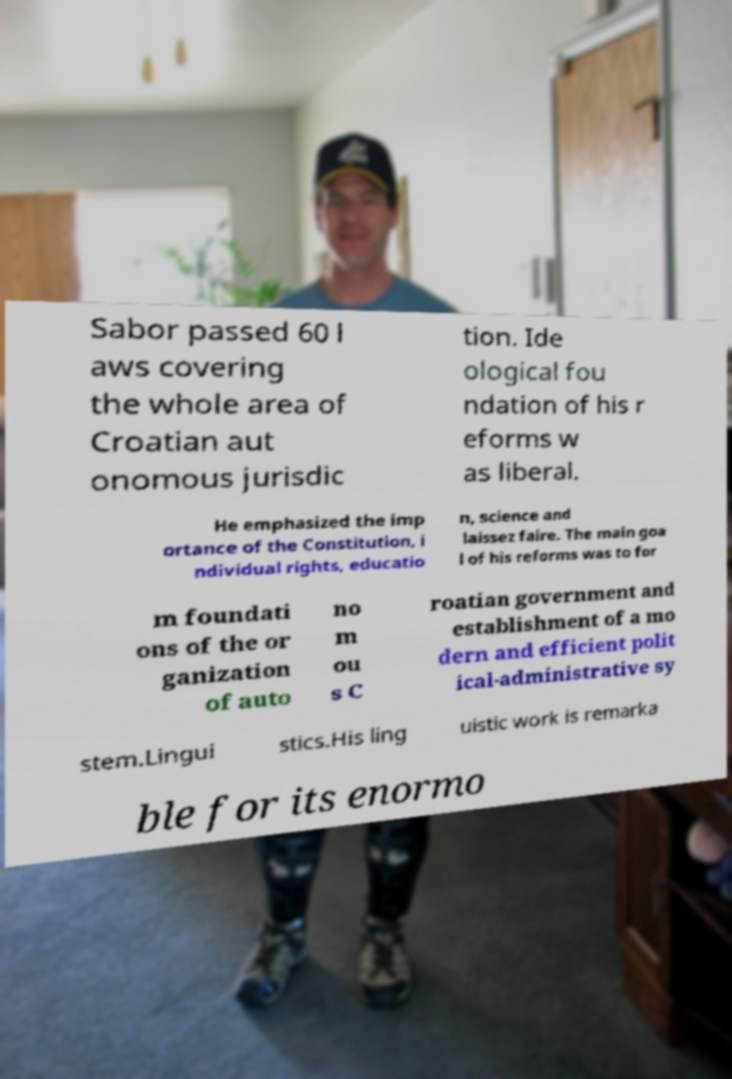Please identify and transcribe the text found in this image. Sabor passed 60 l aws covering the whole area of Croatian aut onomous jurisdic tion. Ide ological fou ndation of his r eforms w as liberal. He emphasized the imp ortance of the Constitution, i ndividual rights, educatio n, science and laissez faire. The main goa l of his reforms was to for m foundati ons of the or ganization of auto no m ou s C roatian government and establishment of a mo dern and efficient polit ical-administrative sy stem.Lingui stics.His ling uistic work is remarka ble for its enormo 